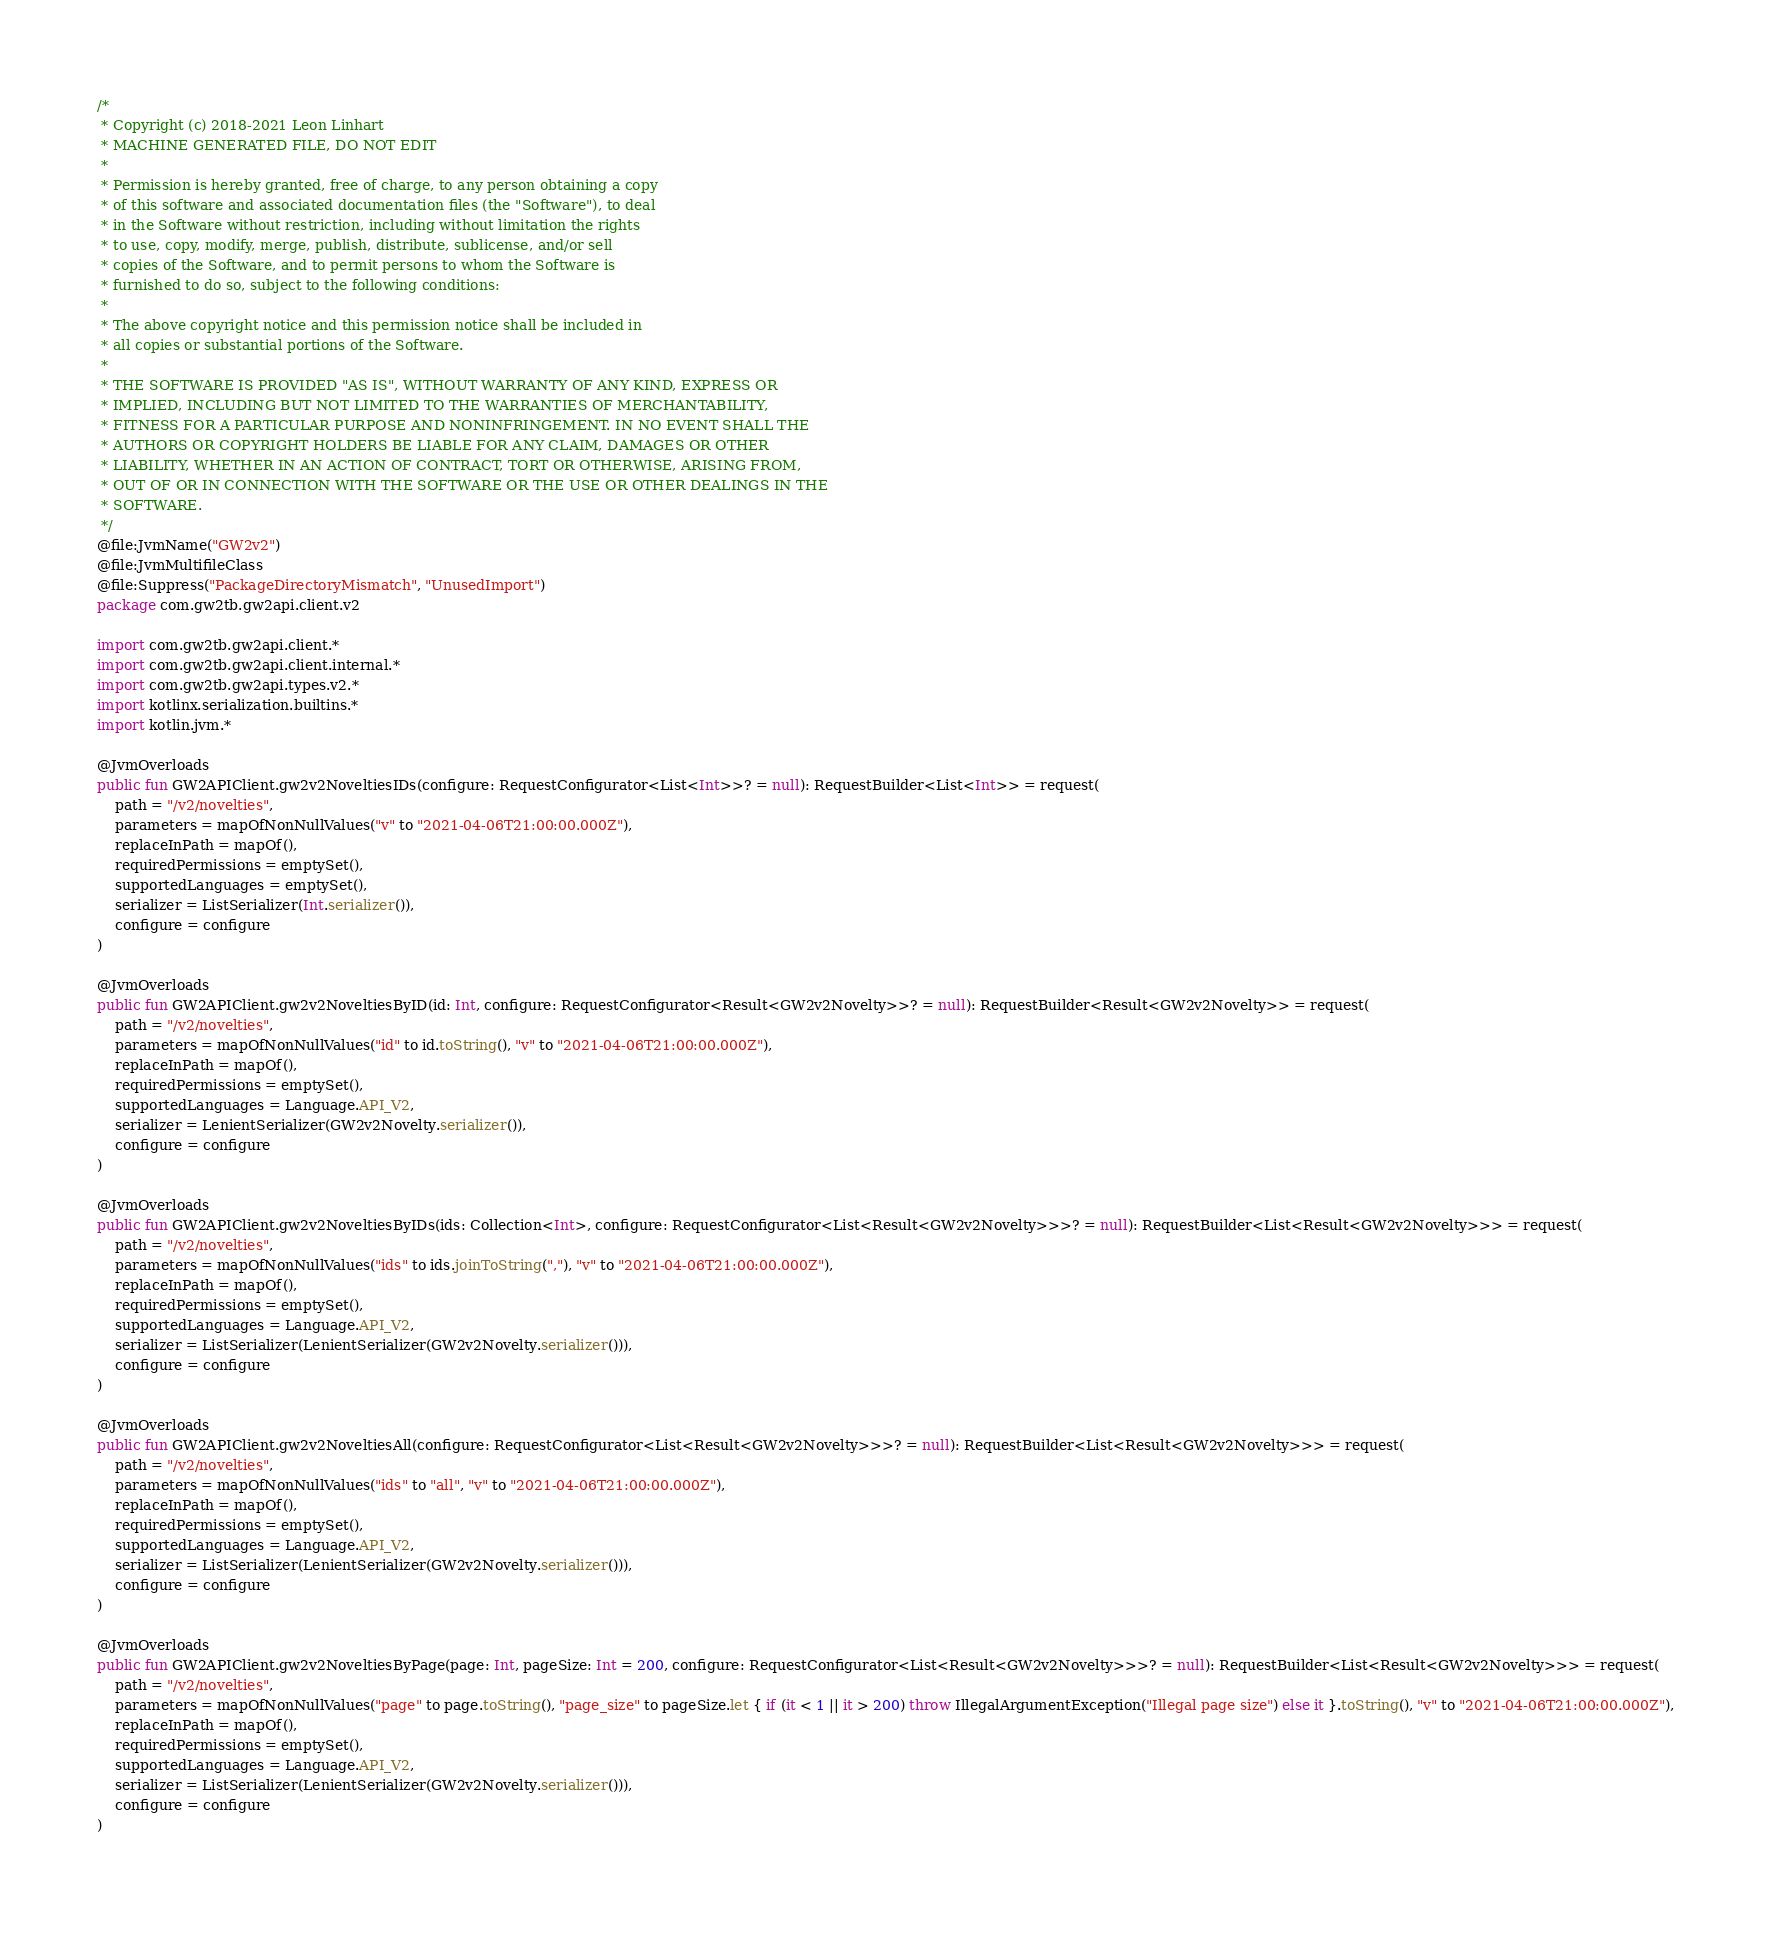Convert code to text. <code><loc_0><loc_0><loc_500><loc_500><_Kotlin_>/*
 * Copyright (c) 2018-2021 Leon Linhart
 * MACHINE GENERATED FILE, DO NOT EDIT
 *
 * Permission is hereby granted, free of charge, to any person obtaining a copy
 * of this software and associated documentation files (the "Software"), to deal
 * in the Software without restriction, including without limitation the rights
 * to use, copy, modify, merge, publish, distribute, sublicense, and/or sell
 * copies of the Software, and to permit persons to whom the Software is
 * furnished to do so, subject to the following conditions:
 *
 * The above copyright notice and this permission notice shall be included in
 * all copies or substantial portions of the Software.
 *
 * THE SOFTWARE IS PROVIDED "AS IS", WITHOUT WARRANTY OF ANY KIND, EXPRESS OR
 * IMPLIED, INCLUDING BUT NOT LIMITED TO THE WARRANTIES OF MERCHANTABILITY,
 * FITNESS FOR A PARTICULAR PURPOSE AND NONINFRINGEMENT. IN NO EVENT SHALL THE
 * AUTHORS OR COPYRIGHT HOLDERS BE LIABLE FOR ANY CLAIM, DAMAGES OR OTHER
 * LIABILITY, WHETHER IN AN ACTION OF CONTRACT, TORT OR OTHERWISE, ARISING FROM,
 * OUT OF OR IN CONNECTION WITH THE SOFTWARE OR THE USE OR OTHER DEALINGS IN THE
 * SOFTWARE.
 */
@file:JvmName("GW2v2")
@file:JvmMultifileClass
@file:Suppress("PackageDirectoryMismatch", "UnusedImport")
package com.gw2tb.gw2api.client.v2

import com.gw2tb.gw2api.client.*
import com.gw2tb.gw2api.client.internal.*
import com.gw2tb.gw2api.types.v2.*
import kotlinx.serialization.builtins.*
import kotlin.jvm.*

@JvmOverloads
public fun GW2APIClient.gw2v2NoveltiesIDs(configure: RequestConfigurator<List<Int>>? = null): RequestBuilder<List<Int>> = request(
    path = "/v2/novelties",
    parameters = mapOfNonNullValues("v" to "2021-04-06T21:00:00.000Z"),
    replaceInPath = mapOf(),
    requiredPermissions = emptySet(),
    supportedLanguages = emptySet(),
    serializer = ListSerializer(Int.serializer()),
    configure = configure
)

@JvmOverloads
public fun GW2APIClient.gw2v2NoveltiesByID(id: Int, configure: RequestConfigurator<Result<GW2v2Novelty>>? = null): RequestBuilder<Result<GW2v2Novelty>> = request(
    path = "/v2/novelties",
    parameters = mapOfNonNullValues("id" to id.toString(), "v" to "2021-04-06T21:00:00.000Z"),
    replaceInPath = mapOf(),
    requiredPermissions = emptySet(),
    supportedLanguages = Language.API_V2,
    serializer = LenientSerializer(GW2v2Novelty.serializer()),
    configure = configure
)

@JvmOverloads
public fun GW2APIClient.gw2v2NoveltiesByIDs(ids: Collection<Int>, configure: RequestConfigurator<List<Result<GW2v2Novelty>>>? = null): RequestBuilder<List<Result<GW2v2Novelty>>> = request(
    path = "/v2/novelties",
    parameters = mapOfNonNullValues("ids" to ids.joinToString(","), "v" to "2021-04-06T21:00:00.000Z"),
    replaceInPath = mapOf(),
    requiredPermissions = emptySet(),
    supportedLanguages = Language.API_V2,
    serializer = ListSerializer(LenientSerializer(GW2v2Novelty.serializer())),
    configure = configure
)

@JvmOverloads
public fun GW2APIClient.gw2v2NoveltiesAll(configure: RequestConfigurator<List<Result<GW2v2Novelty>>>? = null): RequestBuilder<List<Result<GW2v2Novelty>>> = request(
    path = "/v2/novelties",
    parameters = mapOfNonNullValues("ids" to "all", "v" to "2021-04-06T21:00:00.000Z"),
    replaceInPath = mapOf(),
    requiredPermissions = emptySet(),
    supportedLanguages = Language.API_V2,
    serializer = ListSerializer(LenientSerializer(GW2v2Novelty.serializer())),
    configure = configure
)

@JvmOverloads
public fun GW2APIClient.gw2v2NoveltiesByPage(page: Int, pageSize: Int = 200, configure: RequestConfigurator<List<Result<GW2v2Novelty>>>? = null): RequestBuilder<List<Result<GW2v2Novelty>>> = request(
    path = "/v2/novelties",
    parameters = mapOfNonNullValues("page" to page.toString(), "page_size" to pageSize.let { if (it < 1 || it > 200) throw IllegalArgumentException("Illegal page size") else it }.toString(), "v" to "2021-04-06T21:00:00.000Z"),
    replaceInPath = mapOf(),
    requiredPermissions = emptySet(),
    supportedLanguages = Language.API_V2,
    serializer = ListSerializer(LenientSerializer(GW2v2Novelty.serializer())),
    configure = configure
)</code> 